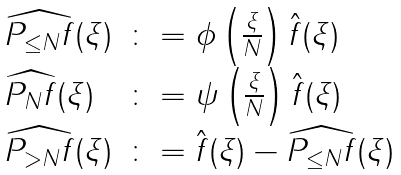<formula> <loc_0><loc_0><loc_500><loc_500>\begin{array} { l l } \widehat { P _ { \leq N } f } ( \xi ) & \colon = \phi \left ( \frac { \xi } { N } \right ) \hat { f } ( \xi ) \\ \widehat { P _ { N } f } ( \xi ) & \colon = \psi \left ( \frac { \xi } { N } \right ) \hat { f } ( \xi ) \\ \widehat { P _ { > N } f } ( \xi ) & \colon = \hat { f } ( \xi ) - \widehat { P _ { \leq N } f } ( \xi ) \end{array}</formula> 